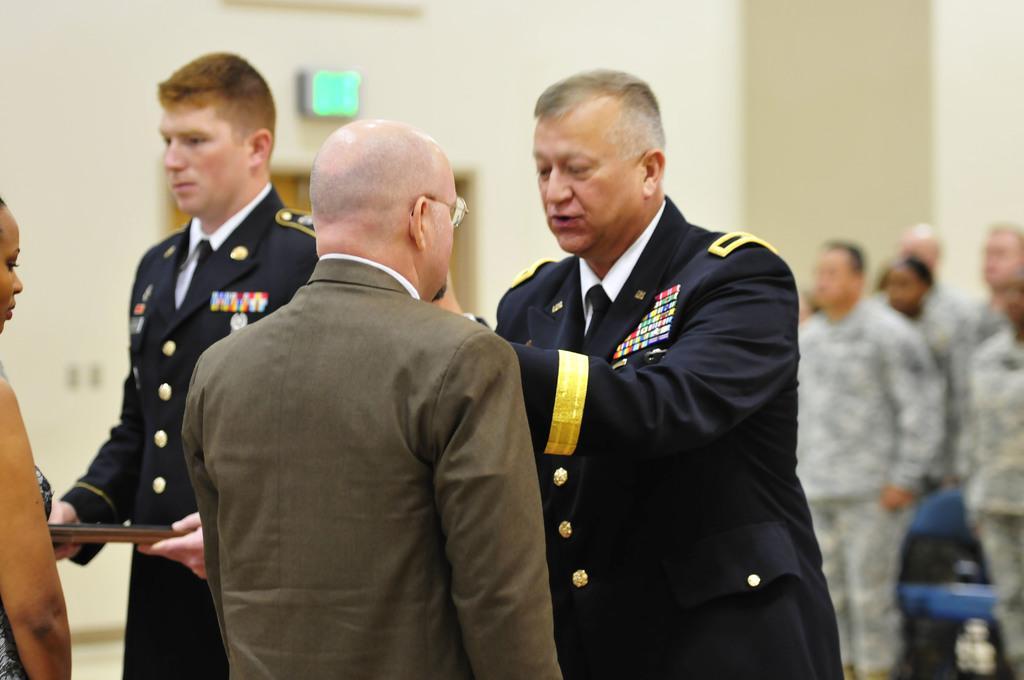Please provide a concise description of this image. In this image there is a man and a woman receiving an honor from the officers, behind them there are a few other army personnel standing. 